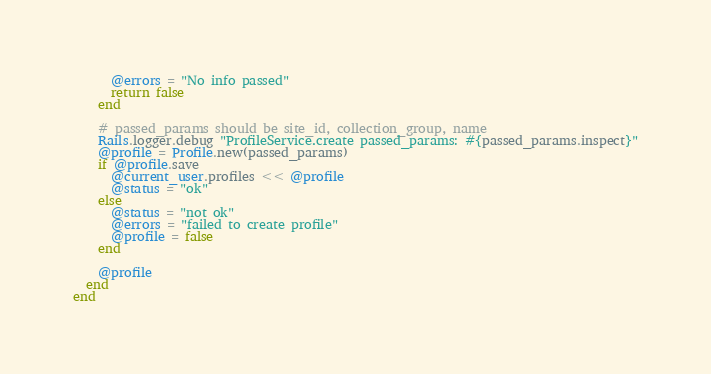<code> <loc_0><loc_0><loc_500><loc_500><_Ruby_>      @errors = "No info passed"
      return false
    end

    # passed_params should be site_id, collection_group, name
    Rails.logger.debug "ProfileService.create passed_params: #{passed_params.inspect}"
    @profile = Profile.new(passed_params)
    if @profile.save
      @current_user.profiles << @profile
      @status = "ok"
    else
      @status = "not ok"
      @errors = "failed to create profile"
      @profile = false
    end

    @profile
  end
end
</code> 